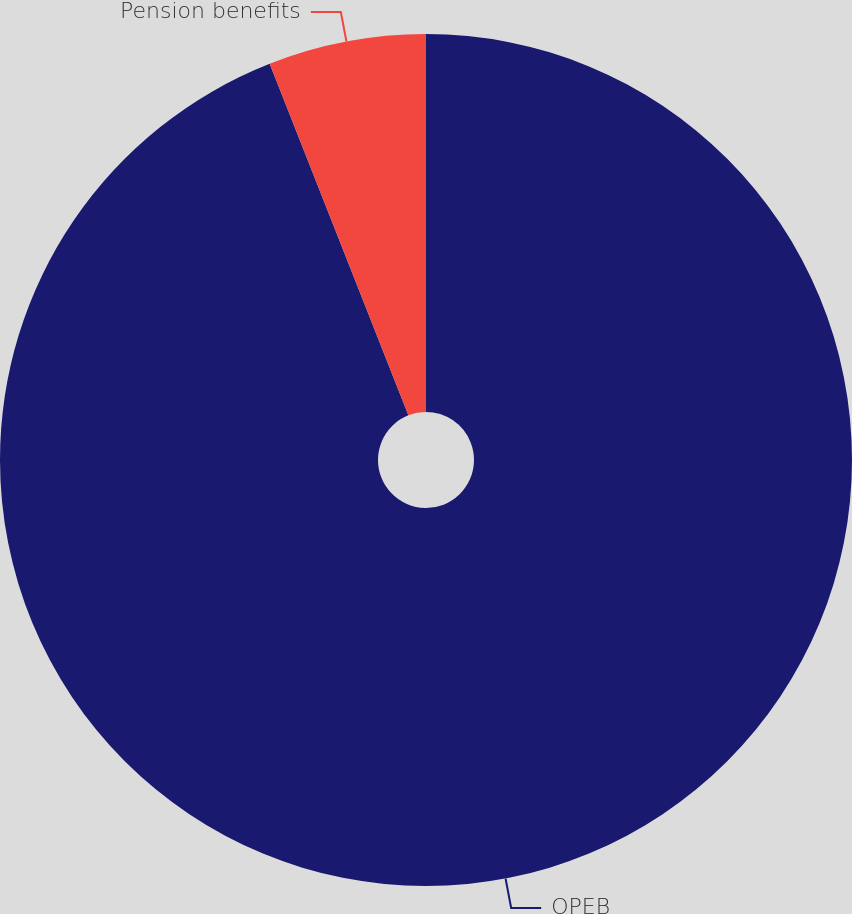<chart> <loc_0><loc_0><loc_500><loc_500><pie_chart><fcel>OPEB<fcel>Pension benefits<nl><fcel>94.02%<fcel>5.98%<nl></chart> 